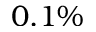Convert formula to latex. <formula><loc_0><loc_0><loc_500><loc_500>0 . 1 \%</formula> 